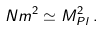<formula> <loc_0><loc_0><loc_500><loc_500>N m ^ { 2 } \simeq M _ { P l } ^ { 2 } \, .</formula> 